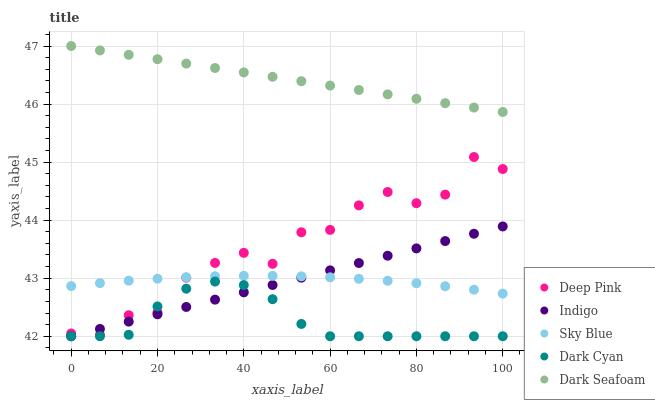Does Dark Cyan have the minimum area under the curve?
Answer yes or no. Yes. Does Dark Seafoam have the maximum area under the curve?
Answer yes or no. Yes. Does Sky Blue have the minimum area under the curve?
Answer yes or no. No. Does Sky Blue have the maximum area under the curve?
Answer yes or no. No. Is Dark Seafoam the smoothest?
Answer yes or no. Yes. Is Deep Pink the roughest?
Answer yes or no. Yes. Is Sky Blue the smoothest?
Answer yes or no. No. Is Sky Blue the roughest?
Answer yes or no. No. Does Dark Cyan have the lowest value?
Answer yes or no. Yes. Does Sky Blue have the lowest value?
Answer yes or no. No. Does Dark Seafoam have the highest value?
Answer yes or no. Yes. Does Sky Blue have the highest value?
Answer yes or no. No. Is Sky Blue less than Dark Seafoam?
Answer yes or no. Yes. Is Dark Seafoam greater than Deep Pink?
Answer yes or no. Yes. Does Dark Cyan intersect Deep Pink?
Answer yes or no. Yes. Is Dark Cyan less than Deep Pink?
Answer yes or no. No. Is Dark Cyan greater than Deep Pink?
Answer yes or no. No. Does Sky Blue intersect Dark Seafoam?
Answer yes or no. No. 